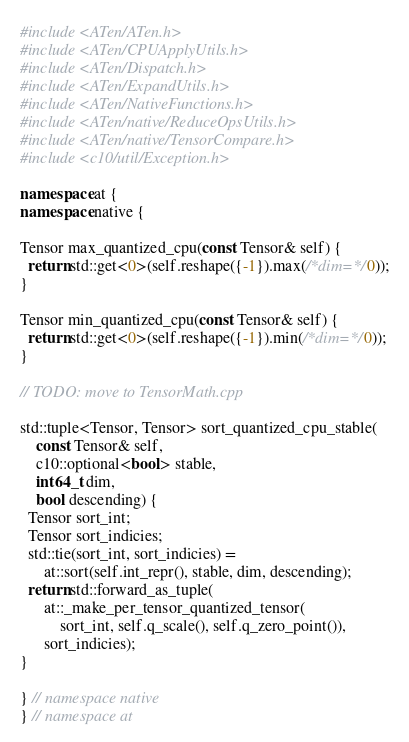<code> <loc_0><loc_0><loc_500><loc_500><_C++_>#include <ATen/ATen.h>
#include <ATen/CPUApplyUtils.h>
#include <ATen/Dispatch.h>
#include <ATen/ExpandUtils.h>
#include <ATen/NativeFunctions.h>
#include <ATen/native/ReduceOpsUtils.h>
#include <ATen/native/TensorCompare.h>
#include <c10/util/Exception.h>

namespace at {
namespace native {

Tensor max_quantized_cpu(const Tensor& self) {
  return std::get<0>(self.reshape({-1}).max(/*dim=*/0));
}

Tensor min_quantized_cpu(const Tensor& self) {
  return std::get<0>(self.reshape({-1}).min(/*dim=*/0));
}

// TODO: move to TensorMath.cpp

std::tuple<Tensor, Tensor> sort_quantized_cpu_stable(
    const Tensor& self,
    c10::optional<bool> stable,
    int64_t dim,
    bool descending) {
  Tensor sort_int;
  Tensor sort_indicies;
  std::tie(sort_int, sort_indicies) =
      at::sort(self.int_repr(), stable, dim, descending);
  return std::forward_as_tuple(
      at::_make_per_tensor_quantized_tensor(
          sort_int, self.q_scale(), self.q_zero_point()),
      sort_indicies);
}

} // namespace native
} // namespace at
</code> 